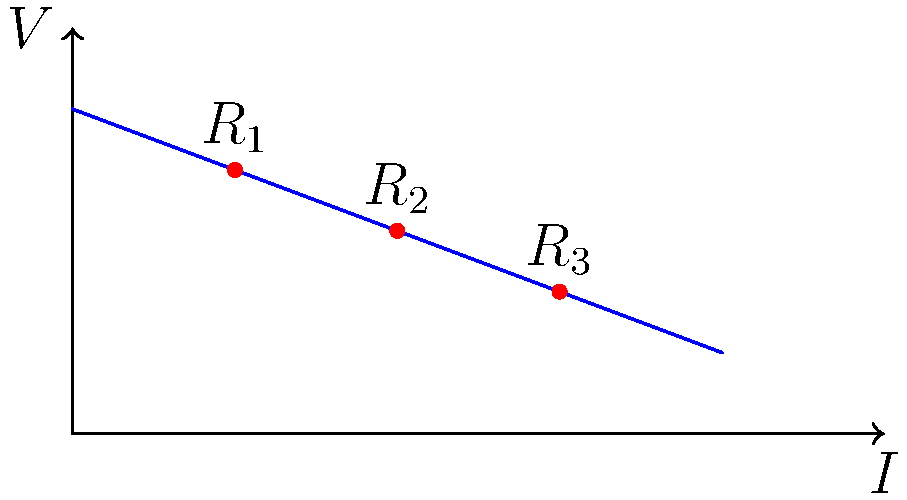As part of your charity work, you're helping set up a small electrical system for a youth sports facility affected by the pandemic. The circuit consists of three resistors connected in series: $R_1 = 10\Omega$, $R_2 = 15\Omega$, and $R_3 = 20\Omega$. If the total voltage across the circuit is 90V, what is the power consumption of the entire circuit? To solve this problem, we'll follow these steps:

1) First, calculate the total resistance of the circuit:
   $R_{total} = R_1 + R_2 + R_3 = 10\Omega + 15\Omega + 20\Omega = 45\Omega$

2) Use Ohm's Law to find the current in the circuit:
   $I = \frac{V}{R_{total}} = \frac{90V}{45\Omega} = 2A$

3) The power consumption can be calculated using the formula:
   $P = VI$ or $P = I^2R$

   Let's use $P = VI$:
   $P = 90V * 2A = 180W$

Therefore, the total power consumption of the circuit is 180 watts.
Answer: 180W 